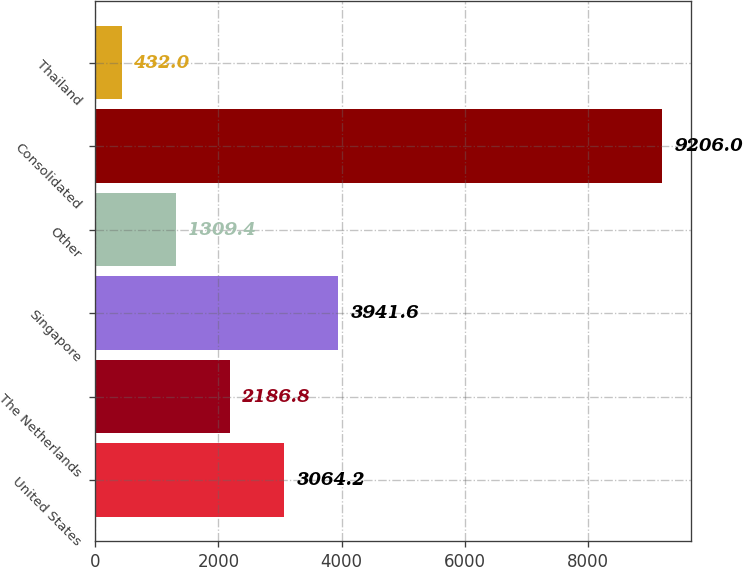Convert chart to OTSL. <chart><loc_0><loc_0><loc_500><loc_500><bar_chart><fcel>United States<fcel>The Netherlands<fcel>Singapore<fcel>Other<fcel>Consolidated<fcel>Thailand<nl><fcel>3064.2<fcel>2186.8<fcel>3941.6<fcel>1309.4<fcel>9206<fcel>432<nl></chart> 